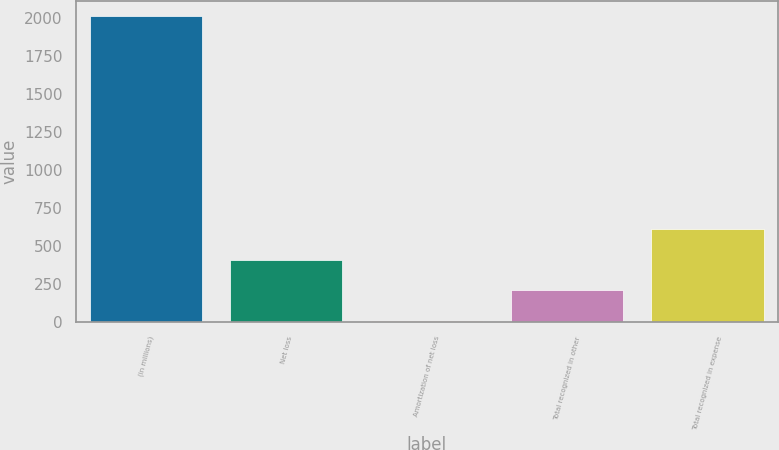Convert chart to OTSL. <chart><loc_0><loc_0><loc_500><loc_500><bar_chart><fcel>(in millions)<fcel>Net loss<fcel>Amortization of net loss<fcel>Total recognized in other<fcel>Total recognized in expense<nl><fcel>2012<fcel>410.4<fcel>10<fcel>210.2<fcel>610.6<nl></chart> 